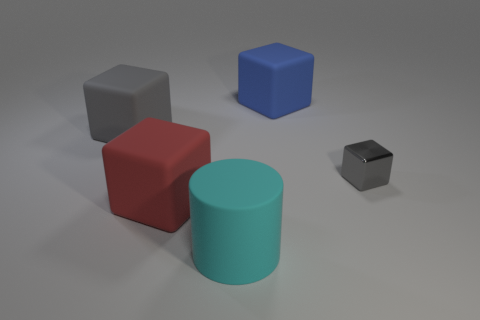Subtract all matte blocks. How many blocks are left? 1 Subtract all cyan balls. How many gray cubes are left? 2 Subtract all red cubes. How many cubes are left? 3 Add 2 big blocks. How many objects exist? 7 Subtract all cylinders. How many objects are left? 4 Subtract all tiny blocks. Subtract all tiny objects. How many objects are left? 3 Add 2 small metallic blocks. How many small metallic blocks are left? 3 Add 2 large cyan things. How many large cyan things exist? 3 Subtract 0 brown cylinders. How many objects are left? 5 Subtract all green cylinders. Subtract all brown balls. How many cylinders are left? 1 